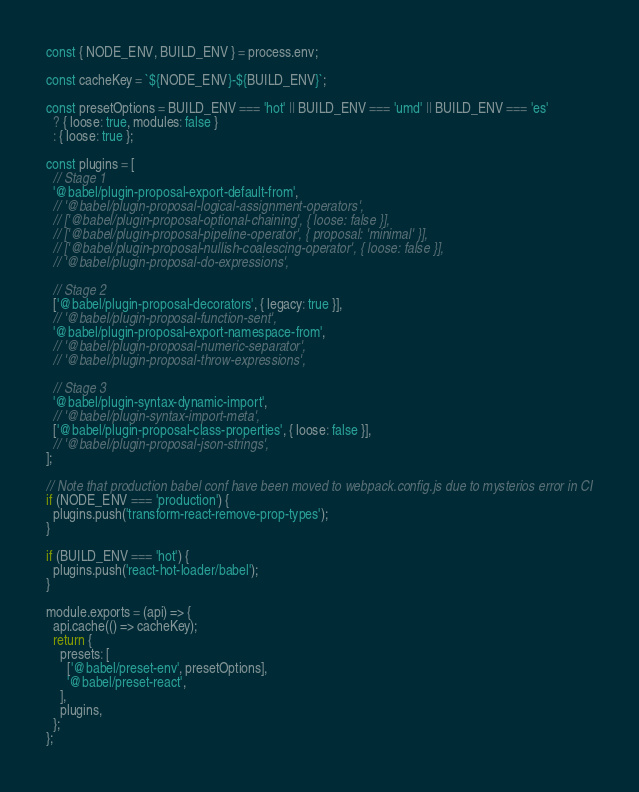Convert code to text. <code><loc_0><loc_0><loc_500><loc_500><_JavaScript_>const { NODE_ENV, BUILD_ENV } = process.env;

const cacheKey = `${NODE_ENV}-${BUILD_ENV}`;

const presetOptions = BUILD_ENV === 'hot' || BUILD_ENV === 'umd' || BUILD_ENV === 'es'
  ? { loose: true, modules: false }
  : { loose: true };

const plugins = [
  // Stage 1
  '@babel/plugin-proposal-export-default-from',
  // '@babel/plugin-proposal-logical-assignment-operators',
  // ['@babel/plugin-proposal-optional-chaining', { loose: false }],
  // ['@babel/plugin-proposal-pipeline-operator', { proposal: 'minimal' }],
  // ['@babel/plugin-proposal-nullish-coalescing-operator', { loose: false }],
  // '@babel/plugin-proposal-do-expressions',

  // Stage 2
  ['@babel/plugin-proposal-decorators', { legacy: true }],
  // '@babel/plugin-proposal-function-sent',
  '@babel/plugin-proposal-export-namespace-from',
  // '@babel/plugin-proposal-numeric-separator',
  // '@babel/plugin-proposal-throw-expressions',

  // Stage 3
  '@babel/plugin-syntax-dynamic-import',
  // '@babel/plugin-syntax-import-meta',
  ['@babel/plugin-proposal-class-properties', { loose: false }],
  // '@babel/plugin-proposal-json-strings',
];

// Note that production babel conf have been moved to webpack.config.js due to mysterios error in CI
if (NODE_ENV === 'production') {
  plugins.push('transform-react-remove-prop-types');
}

if (BUILD_ENV === 'hot') {
  plugins.push('react-hot-loader/babel');
}

module.exports = (api) => {
  api.cache(() => cacheKey);
  return {
    presets: [
      ['@babel/preset-env', presetOptions],
      '@babel/preset-react',
    ],
    plugins,
  };
};
</code> 